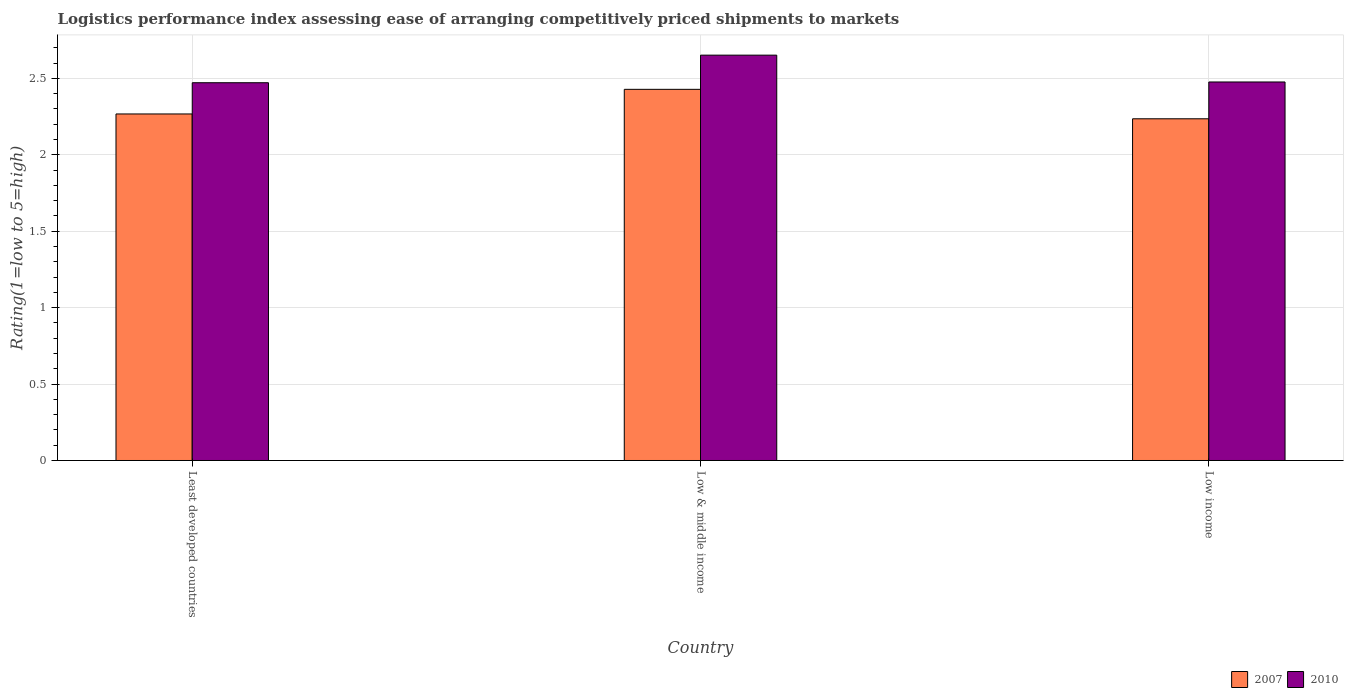How many different coloured bars are there?
Give a very brief answer. 2. Are the number of bars per tick equal to the number of legend labels?
Offer a very short reply. Yes. How many bars are there on the 3rd tick from the right?
Provide a short and direct response. 2. In how many cases, is the number of bars for a given country not equal to the number of legend labels?
Your answer should be very brief. 0. What is the Logistic performance index in 2010 in Least developed countries?
Provide a short and direct response. 2.47. Across all countries, what is the maximum Logistic performance index in 2010?
Offer a terse response. 2.65. Across all countries, what is the minimum Logistic performance index in 2007?
Provide a succinct answer. 2.24. What is the total Logistic performance index in 2007 in the graph?
Your answer should be compact. 6.93. What is the difference between the Logistic performance index in 2010 in Least developed countries and that in Low income?
Provide a succinct answer. -0. What is the difference between the Logistic performance index in 2010 in Least developed countries and the Logistic performance index in 2007 in Low & middle income?
Your response must be concise. 0.04. What is the average Logistic performance index in 2007 per country?
Offer a very short reply. 2.31. What is the difference between the Logistic performance index of/in 2010 and Logistic performance index of/in 2007 in Low income?
Provide a succinct answer. 0.24. What is the ratio of the Logistic performance index in 2007 in Least developed countries to that in Low & middle income?
Your answer should be compact. 0.93. Is the difference between the Logistic performance index in 2010 in Least developed countries and Low & middle income greater than the difference between the Logistic performance index in 2007 in Least developed countries and Low & middle income?
Give a very brief answer. No. What is the difference between the highest and the second highest Logistic performance index in 2010?
Your answer should be compact. 0.18. What is the difference between the highest and the lowest Logistic performance index in 2010?
Your answer should be compact. 0.18. How many bars are there?
Provide a short and direct response. 6. How many countries are there in the graph?
Your answer should be very brief. 3. What is the difference between two consecutive major ticks on the Y-axis?
Make the answer very short. 0.5. Are the values on the major ticks of Y-axis written in scientific E-notation?
Keep it short and to the point. No. Does the graph contain grids?
Provide a succinct answer. Yes. Where does the legend appear in the graph?
Your answer should be compact. Bottom right. How many legend labels are there?
Make the answer very short. 2. What is the title of the graph?
Provide a short and direct response. Logistics performance index assessing ease of arranging competitively priced shipments to markets. Does "2001" appear as one of the legend labels in the graph?
Make the answer very short. No. What is the label or title of the Y-axis?
Provide a short and direct response. Rating(1=low to 5=high). What is the Rating(1=low to 5=high) in 2007 in Least developed countries?
Your response must be concise. 2.27. What is the Rating(1=low to 5=high) of 2010 in Least developed countries?
Offer a very short reply. 2.47. What is the Rating(1=low to 5=high) in 2007 in Low & middle income?
Offer a terse response. 2.43. What is the Rating(1=low to 5=high) in 2010 in Low & middle income?
Make the answer very short. 2.65. What is the Rating(1=low to 5=high) in 2007 in Low income?
Ensure brevity in your answer.  2.24. What is the Rating(1=low to 5=high) of 2010 in Low income?
Your answer should be very brief. 2.48. Across all countries, what is the maximum Rating(1=low to 5=high) in 2007?
Give a very brief answer. 2.43. Across all countries, what is the maximum Rating(1=low to 5=high) in 2010?
Your response must be concise. 2.65. Across all countries, what is the minimum Rating(1=low to 5=high) of 2007?
Ensure brevity in your answer.  2.24. Across all countries, what is the minimum Rating(1=low to 5=high) in 2010?
Your answer should be compact. 2.47. What is the total Rating(1=low to 5=high) in 2007 in the graph?
Your answer should be compact. 6.93. What is the total Rating(1=low to 5=high) of 2010 in the graph?
Provide a short and direct response. 7.6. What is the difference between the Rating(1=low to 5=high) in 2007 in Least developed countries and that in Low & middle income?
Ensure brevity in your answer.  -0.16. What is the difference between the Rating(1=low to 5=high) of 2010 in Least developed countries and that in Low & middle income?
Ensure brevity in your answer.  -0.18. What is the difference between the Rating(1=low to 5=high) of 2007 in Least developed countries and that in Low income?
Offer a very short reply. 0.03. What is the difference between the Rating(1=low to 5=high) of 2010 in Least developed countries and that in Low income?
Keep it short and to the point. -0. What is the difference between the Rating(1=low to 5=high) of 2007 in Low & middle income and that in Low income?
Provide a short and direct response. 0.19. What is the difference between the Rating(1=low to 5=high) in 2010 in Low & middle income and that in Low income?
Give a very brief answer. 0.18. What is the difference between the Rating(1=low to 5=high) of 2007 in Least developed countries and the Rating(1=low to 5=high) of 2010 in Low & middle income?
Give a very brief answer. -0.38. What is the difference between the Rating(1=low to 5=high) of 2007 in Least developed countries and the Rating(1=low to 5=high) of 2010 in Low income?
Make the answer very short. -0.21. What is the difference between the Rating(1=low to 5=high) of 2007 in Low & middle income and the Rating(1=low to 5=high) of 2010 in Low income?
Provide a succinct answer. -0.05. What is the average Rating(1=low to 5=high) in 2007 per country?
Provide a succinct answer. 2.31. What is the average Rating(1=low to 5=high) in 2010 per country?
Keep it short and to the point. 2.53. What is the difference between the Rating(1=low to 5=high) of 2007 and Rating(1=low to 5=high) of 2010 in Least developed countries?
Offer a very short reply. -0.2. What is the difference between the Rating(1=low to 5=high) in 2007 and Rating(1=low to 5=high) in 2010 in Low & middle income?
Your answer should be compact. -0.22. What is the difference between the Rating(1=low to 5=high) in 2007 and Rating(1=low to 5=high) in 2010 in Low income?
Offer a terse response. -0.24. What is the ratio of the Rating(1=low to 5=high) in 2007 in Least developed countries to that in Low & middle income?
Ensure brevity in your answer.  0.93. What is the ratio of the Rating(1=low to 5=high) of 2010 in Least developed countries to that in Low & middle income?
Ensure brevity in your answer.  0.93. What is the ratio of the Rating(1=low to 5=high) of 2007 in Least developed countries to that in Low income?
Provide a short and direct response. 1.01. What is the ratio of the Rating(1=low to 5=high) in 2010 in Least developed countries to that in Low income?
Make the answer very short. 1. What is the ratio of the Rating(1=low to 5=high) in 2007 in Low & middle income to that in Low income?
Keep it short and to the point. 1.09. What is the ratio of the Rating(1=low to 5=high) in 2010 in Low & middle income to that in Low income?
Offer a terse response. 1.07. What is the difference between the highest and the second highest Rating(1=low to 5=high) in 2007?
Your answer should be compact. 0.16. What is the difference between the highest and the second highest Rating(1=low to 5=high) of 2010?
Your answer should be compact. 0.18. What is the difference between the highest and the lowest Rating(1=low to 5=high) in 2007?
Your answer should be very brief. 0.19. What is the difference between the highest and the lowest Rating(1=low to 5=high) of 2010?
Make the answer very short. 0.18. 